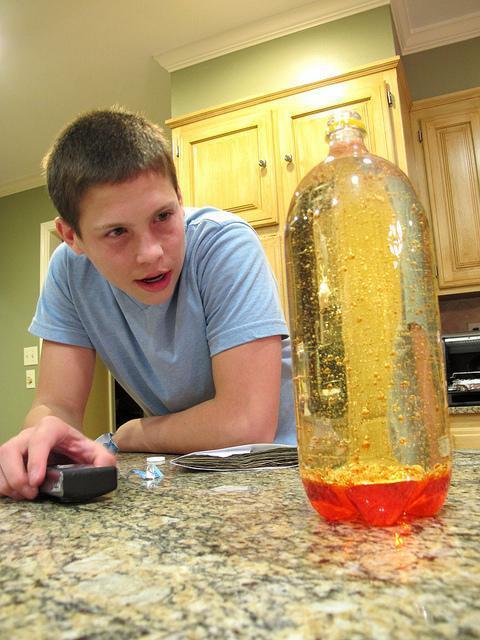How many books are visible?
Give a very brief answer. 1. How many pieces of pizza are missing?
Give a very brief answer. 0. 